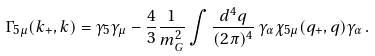<formula> <loc_0><loc_0><loc_500><loc_500>\Gamma _ { 5 \mu } ( k _ { + } , k ) = \gamma _ { 5 } \gamma _ { \mu } - \frac { 4 } { 3 } \frac { 1 } { m _ { G } ^ { 2 } } \int \frac { d ^ { 4 } q } { ( 2 \pi ) ^ { 4 } } \, \gamma _ { \alpha } \chi _ { 5 \mu } ( q _ { + } , q ) \gamma _ { \alpha } \, .</formula> 